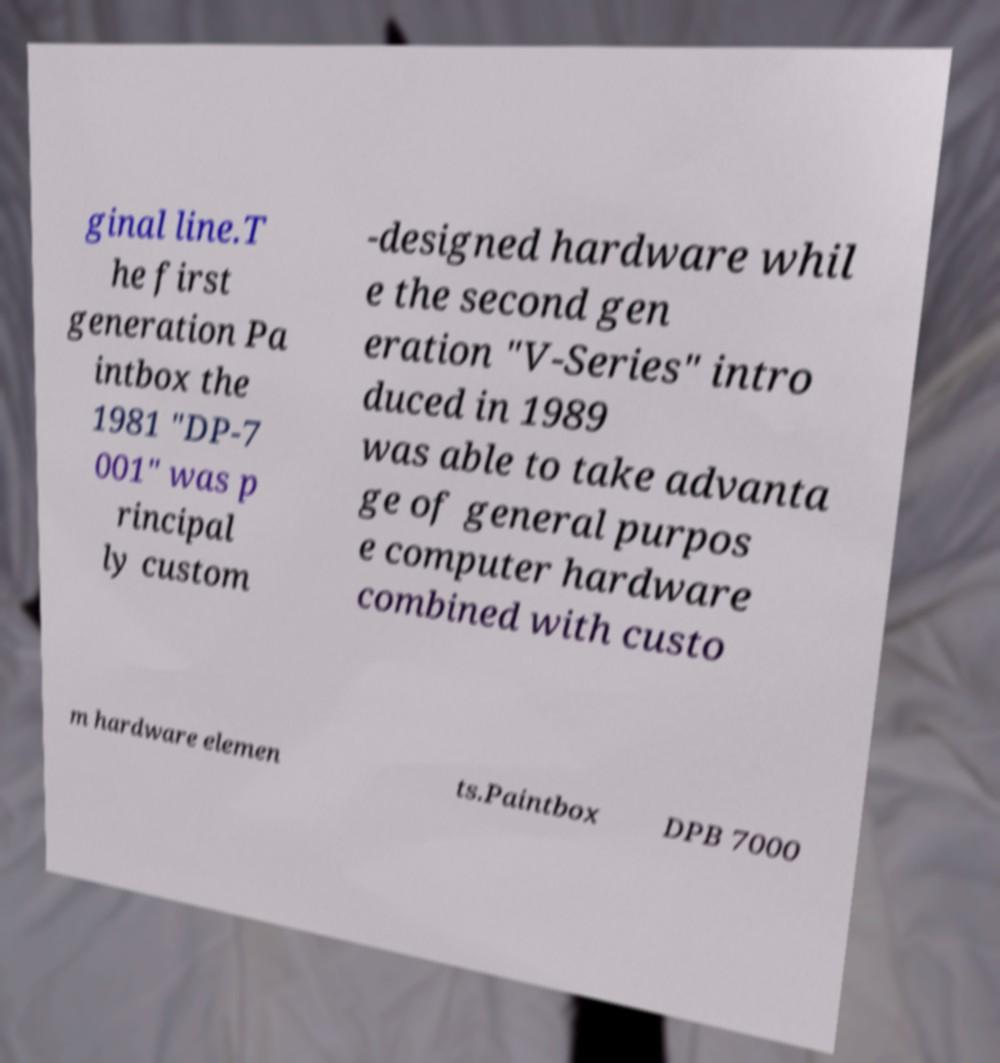There's text embedded in this image that I need extracted. Can you transcribe it verbatim? ginal line.T he first generation Pa intbox the 1981 "DP-7 001" was p rincipal ly custom -designed hardware whil e the second gen eration "V-Series" intro duced in 1989 was able to take advanta ge of general purpos e computer hardware combined with custo m hardware elemen ts.Paintbox DPB 7000 